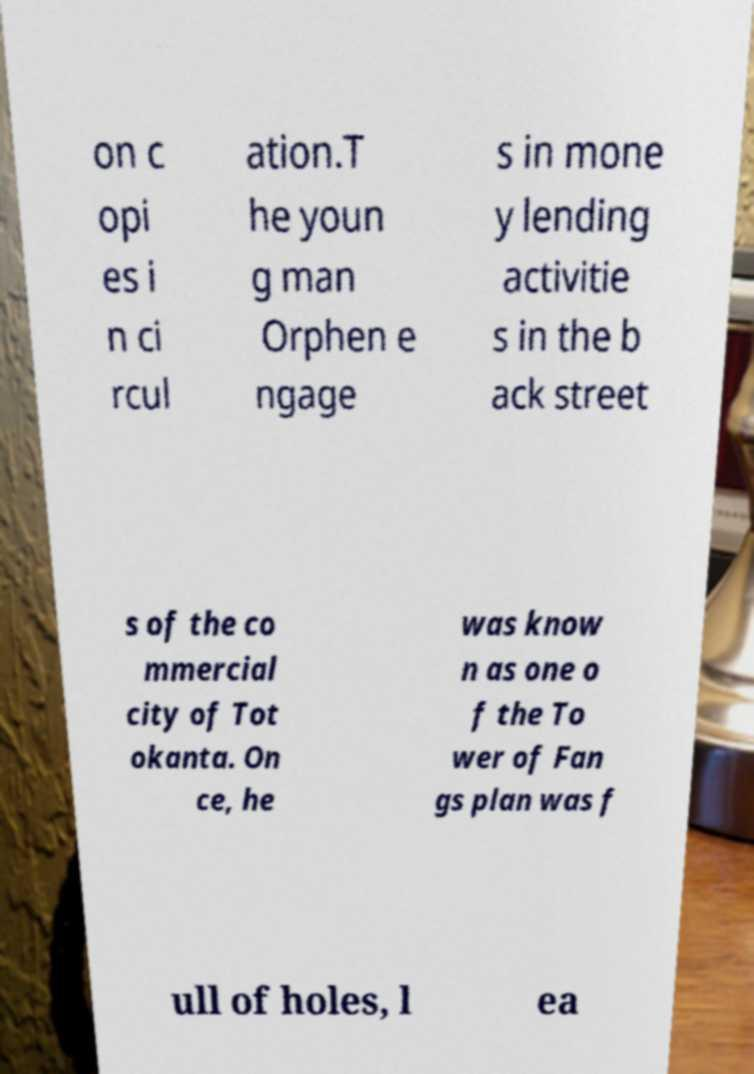Could you assist in decoding the text presented in this image and type it out clearly? on c opi es i n ci rcul ation.T he youn g man Orphen e ngage s in mone y lending activitie s in the b ack street s of the co mmercial city of Tot okanta. On ce, he was know n as one o f the To wer of Fan gs plan was f ull of holes, l ea 